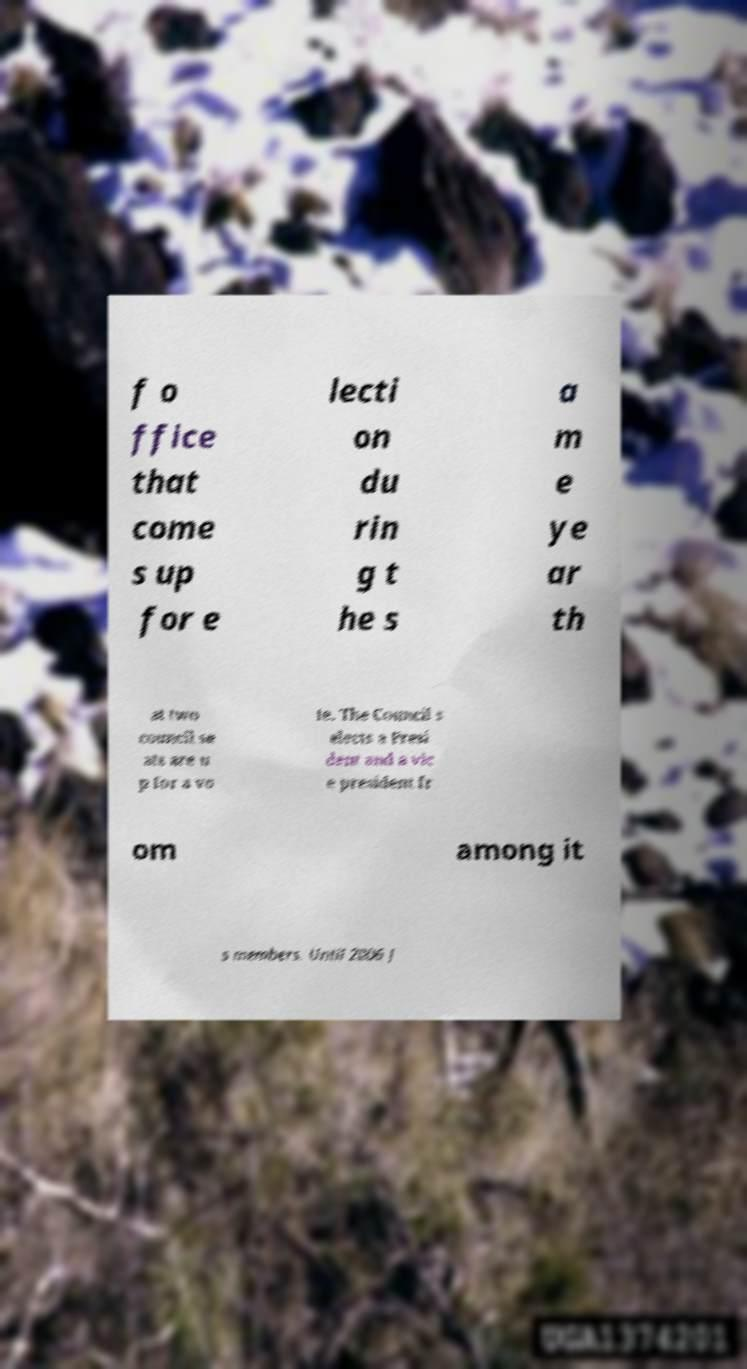I need the written content from this picture converted into text. Can you do that? f o ffice that come s up for e lecti on du rin g t he s a m e ye ar th at two council se ats are u p for a vo te. The Council s elects a Presi dent and a vic e president fr om among it s members. Until 2006 J 